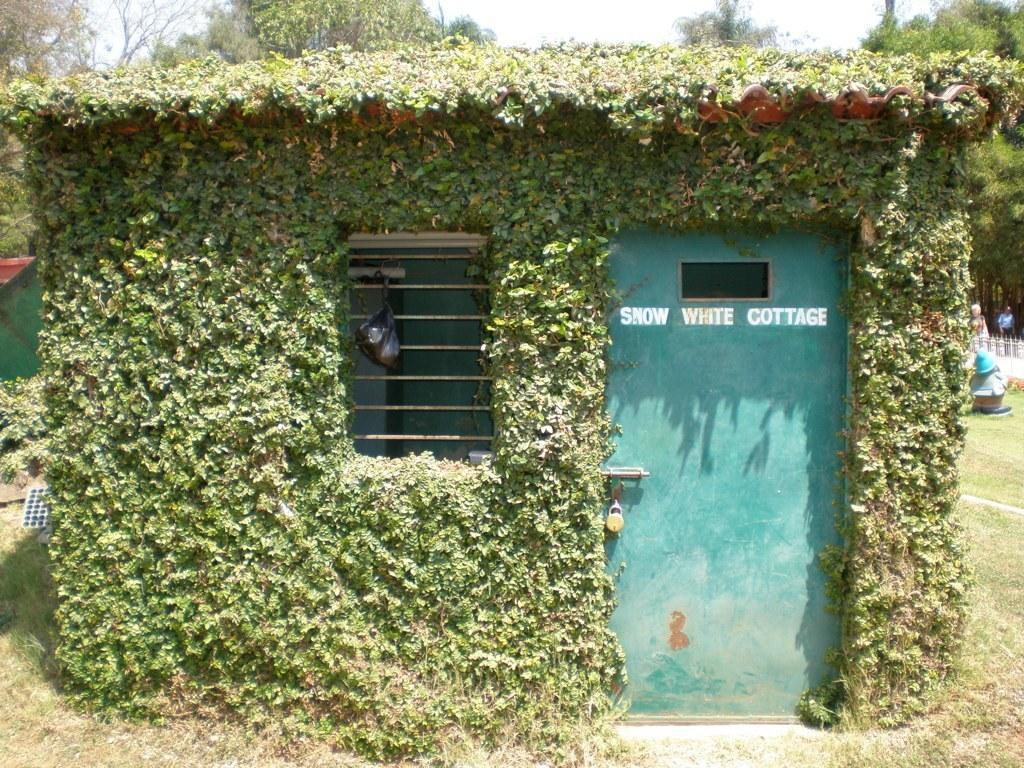Please provide a concise description of this image. In the center of the image we can see a house which is covered with climbing plants and also we can see a door, lock, window, plastic cover. In the background of the image we can see the trees. On the right side of the image we can see the barricades and two persons. At the bottom of the image we can see the ground. At the top of the image we can see the sky. 